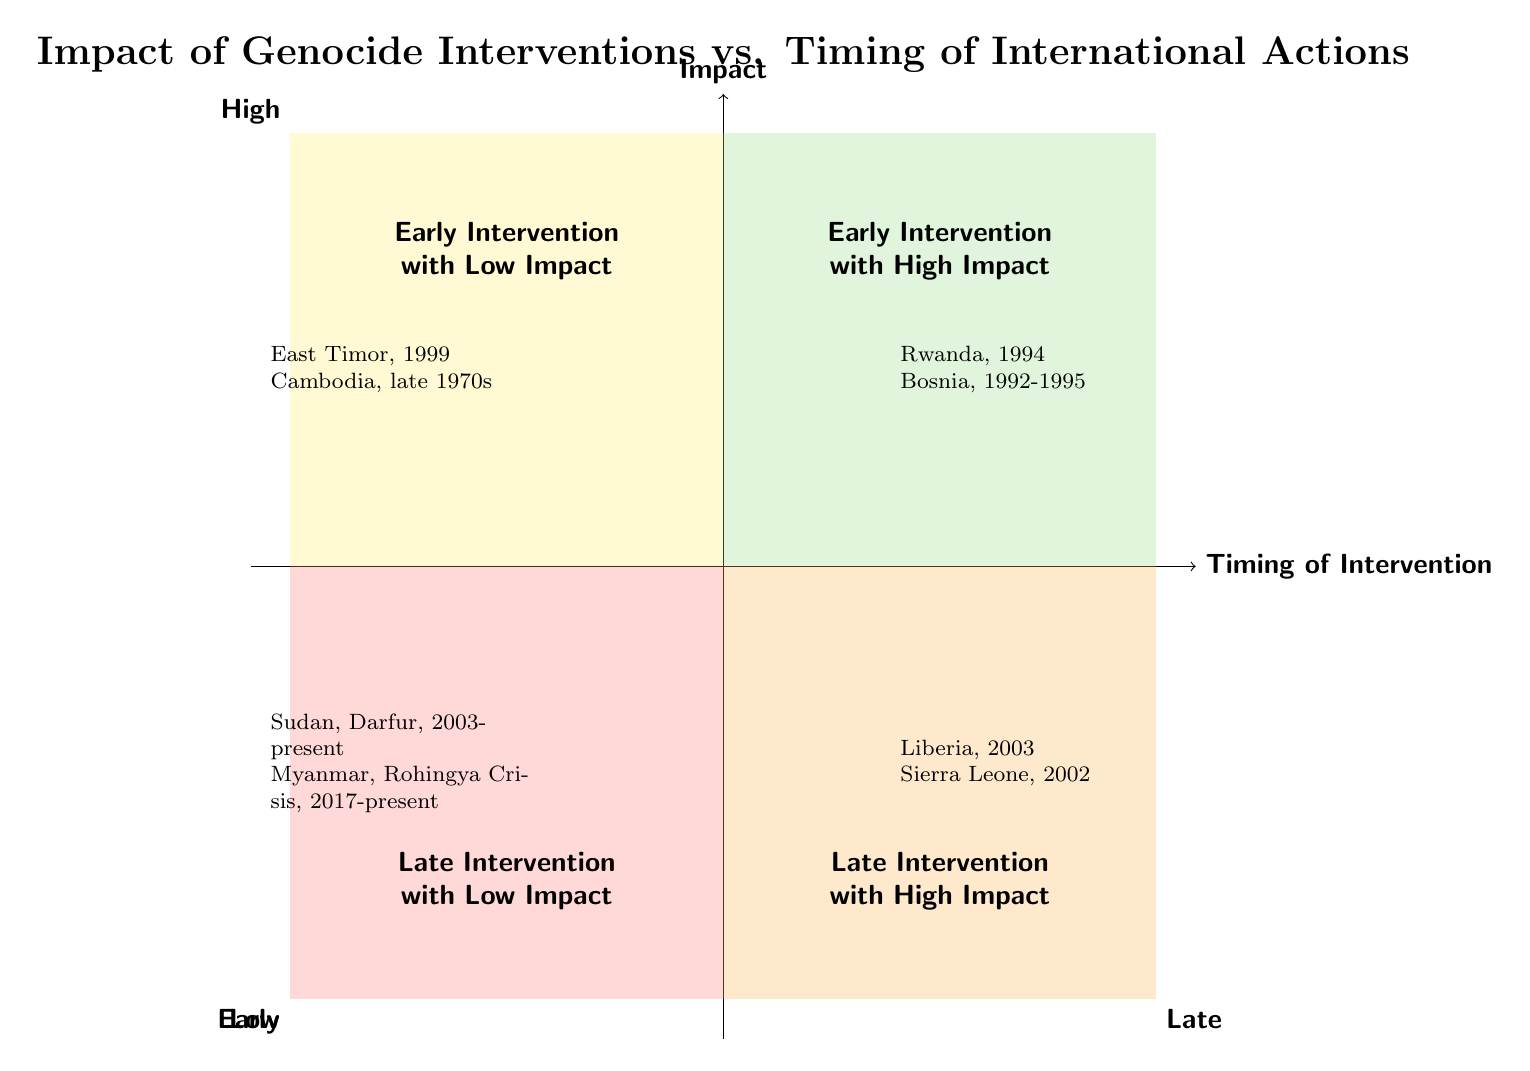What are the two categories on the X-axis? The X-axis of the diagram is labeled with "Timing of Intervention," divided into two categories: "Early" on the left and "Late" on the right.
Answer: Early, Late How many cases are listed in the "Early Intervention with High Impact" quadrant? The "Early Intervention with High Impact" quadrant contains two cases: Rwanda, 1994 and Bosnia, 1992-1995. Therefore, the total is two.
Answer: 2 Which quadrant contains the case of “Sudan, Darfur, 2003-present”? The case “Sudan, Darfur, 2003-present” is mentioned in the "Late Intervention with Low Impact" quadrant, found in the bottom left of the chart.
Answer: Late Intervention with Low Impact What is the main outcome of the intervention in Rwanda, 1994 as per the diagram? According to the diagram, the outcome of the intervention in Rwanda, 1994 is described as potentially saving 800,000 lives, illustrating the high impact of early intervention.
Answer: Saving 800,000 lives Which intervention is associated with the lowest impact among the four quadrants? The intervention associated with the lowest impact is depicted in the "Late Intervention with Low Impact" quadrant, specifically the interventions in "Sudan, Darfur, 2003-present" and "Myanmar, Rohingya Crisis, 2017-present". Since these cases reflect prolonged conflicts with limited success, they illustrate minimal impact.
Answer: Sudan, Darfur What does the “Late Intervention with High Impact” quadrant illustrate in terms of intervention timing? The "Late Intervention with High Impact" quadrant illustrates that while interventions occur late, they can still achieve significant positive outcomes, such as the successful end to conflicts in Liberia, 2003 and Sierra Leone, 2002.
Answer: Significant positive outcomes Which quadrant features the examples of “East Timor, 1999” and “Cambodia, late 1970s”? The examples of "East Timor, 1999" and "Cambodia, late 1970s" are found in the "Early Intervention with Low Impact" quadrant, indicating that early actions had limited immediate success.
Answer: Early Intervention with Low Impact What is the general relationship between intervention timing and impact in this diagram? The diagram suggests a relationship where early intervention tends to correlate with higher impact outcomes, while late intervention may have high impact but generally shows lower success in the prolonged conflicts depicted in the lower quadrants.
Answer: Early intervention correlates with higher impact 